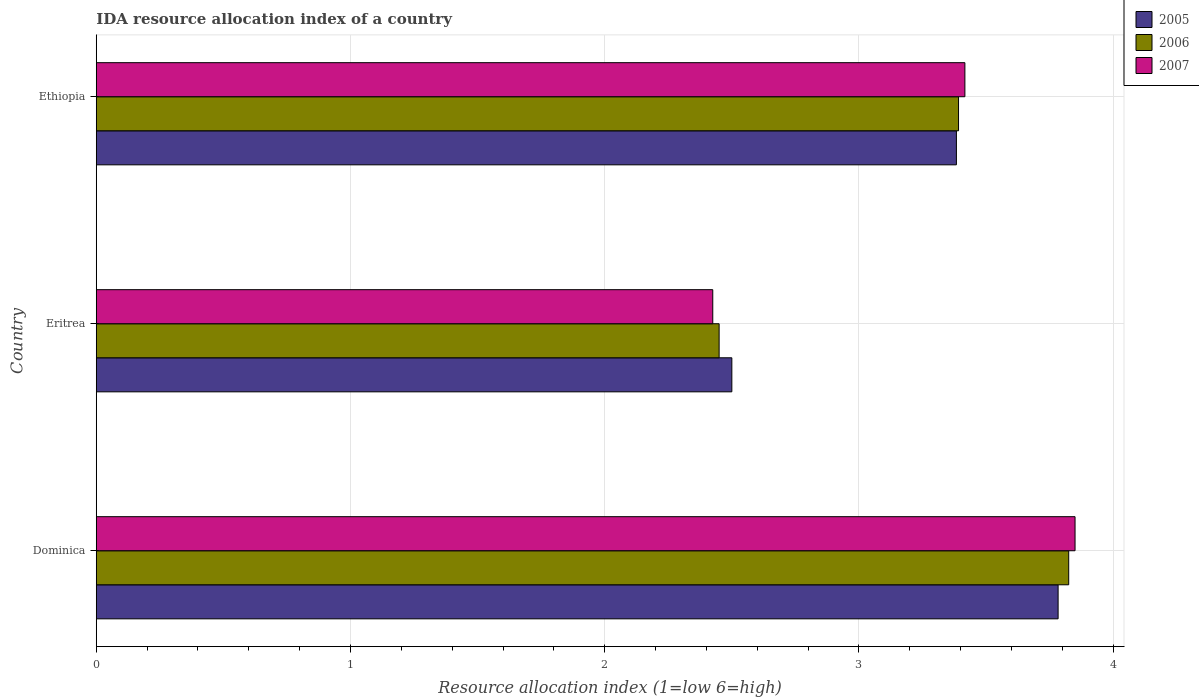Are the number of bars per tick equal to the number of legend labels?
Give a very brief answer. Yes. Are the number of bars on each tick of the Y-axis equal?
Offer a very short reply. Yes. How many bars are there on the 1st tick from the top?
Offer a terse response. 3. What is the label of the 3rd group of bars from the top?
Provide a succinct answer. Dominica. In how many cases, is the number of bars for a given country not equal to the number of legend labels?
Provide a short and direct response. 0. What is the IDA resource allocation index in 2006 in Eritrea?
Ensure brevity in your answer.  2.45. Across all countries, what is the maximum IDA resource allocation index in 2006?
Provide a succinct answer. 3.83. Across all countries, what is the minimum IDA resource allocation index in 2005?
Your answer should be compact. 2.5. In which country was the IDA resource allocation index in 2005 maximum?
Ensure brevity in your answer.  Dominica. In which country was the IDA resource allocation index in 2006 minimum?
Your answer should be very brief. Eritrea. What is the total IDA resource allocation index in 2006 in the graph?
Provide a succinct answer. 9.67. What is the difference between the IDA resource allocation index in 2005 in Dominica and that in Eritrea?
Give a very brief answer. 1.28. What is the difference between the IDA resource allocation index in 2005 in Dominica and the IDA resource allocation index in 2007 in Ethiopia?
Provide a succinct answer. 0.37. What is the average IDA resource allocation index in 2006 per country?
Make the answer very short. 3.22. What is the difference between the IDA resource allocation index in 2005 and IDA resource allocation index in 2007 in Dominica?
Offer a terse response. -0.07. What is the ratio of the IDA resource allocation index in 2007 in Dominica to that in Eritrea?
Your answer should be very brief. 1.59. Is the IDA resource allocation index in 2006 in Dominica less than that in Ethiopia?
Provide a short and direct response. No. What is the difference between the highest and the second highest IDA resource allocation index in 2006?
Offer a terse response. 0.43. What is the difference between the highest and the lowest IDA resource allocation index in 2006?
Provide a short and direct response. 1.38. Is it the case that in every country, the sum of the IDA resource allocation index in 2006 and IDA resource allocation index in 2005 is greater than the IDA resource allocation index in 2007?
Provide a succinct answer. Yes. How many bars are there?
Give a very brief answer. 9. What is the difference between two consecutive major ticks on the X-axis?
Your answer should be very brief. 1. Does the graph contain any zero values?
Provide a succinct answer. No. Does the graph contain grids?
Offer a terse response. Yes. How many legend labels are there?
Your answer should be very brief. 3. What is the title of the graph?
Offer a very short reply. IDA resource allocation index of a country. What is the label or title of the X-axis?
Your answer should be very brief. Resource allocation index (1=low 6=high). What is the label or title of the Y-axis?
Give a very brief answer. Country. What is the Resource allocation index (1=low 6=high) of 2005 in Dominica?
Ensure brevity in your answer.  3.78. What is the Resource allocation index (1=low 6=high) in 2006 in Dominica?
Offer a terse response. 3.83. What is the Resource allocation index (1=low 6=high) of 2007 in Dominica?
Make the answer very short. 3.85. What is the Resource allocation index (1=low 6=high) of 2006 in Eritrea?
Provide a succinct answer. 2.45. What is the Resource allocation index (1=low 6=high) in 2007 in Eritrea?
Your answer should be very brief. 2.42. What is the Resource allocation index (1=low 6=high) in 2005 in Ethiopia?
Offer a terse response. 3.38. What is the Resource allocation index (1=low 6=high) in 2006 in Ethiopia?
Offer a very short reply. 3.39. What is the Resource allocation index (1=low 6=high) of 2007 in Ethiopia?
Keep it short and to the point. 3.42. Across all countries, what is the maximum Resource allocation index (1=low 6=high) in 2005?
Your response must be concise. 3.78. Across all countries, what is the maximum Resource allocation index (1=low 6=high) in 2006?
Make the answer very short. 3.83. Across all countries, what is the maximum Resource allocation index (1=low 6=high) in 2007?
Provide a succinct answer. 3.85. Across all countries, what is the minimum Resource allocation index (1=low 6=high) in 2006?
Provide a succinct answer. 2.45. Across all countries, what is the minimum Resource allocation index (1=low 6=high) of 2007?
Ensure brevity in your answer.  2.42. What is the total Resource allocation index (1=low 6=high) in 2005 in the graph?
Your response must be concise. 9.67. What is the total Resource allocation index (1=low 6=high) in 2006 in the graph?
Your answer should be compact. 9.67. What is the total Resource allocation index (1=low 6=high) of 2007 in the graph?
Offer a very short reply. 9.69. What is the difference between the Resource allocation index (1=low 6=high) of 2005 in Dominica and that in Eritrea?
Provide a short and direct response. 1.28. What is the difference between the Resource allocation index (1=low 6=high) in 2006 in Dominica and that in Eritrea?
Keep it short and to the point. 1.38. What is the difference between the Resource allocation index (1=low 6=high) in 2007 in Dominica and that in Eritrea?
Your answer should be very brief. 1.43. What is the difference between the Resource allocation index (1=low 6=high) in 2006 in Dominica and that in Ethiopia?
Provide a succinct answer. 0.43. What is the difference between the Resource allocation index (1=low 6=high) in 2007 in Dominica and that in Ethiopia?
Your answer should be compact. 0.43. What is the difference between the Resource allocation index (1=low 6=high) of 2005 in Eritrea and that in Ethiopia?
Your answer should be compact. -0.88. What is the difference between the Resource allocation index (1=low 6=high) of 2006 in Eritrea and that in Ethiopia?
Your response must be concise. -0.94. What is the difference between the Resource allocation index (1=low 6=high) in 2007 in Eritrea and that in Ethiopia?
Ensure brevity in your answer.  -0.99. What is the difference between the Resource allocation index (1=low 6=high) of 2005 in Dominica and the Resource allocation index (1=low 6=high) of 2006 in Eritrea?
Make the answer very short. 1.33. What is the difference between the Resource allocation index (1=low 6=high) in 2005 in Dominica and the Resource allocation index (1=low 6=high) in 2007 in Eritrea?
Offer a terse response. 1.36. What is the difference between the Resource allocation index (1=low 6=high) of 2005 in Dominica and the Resource allocation index (1=low 6=high) of 2006 in Ethiopia?
Your answer should be compact. 0.39. What is the difference between the Resource allocation index (1=low 6=high) of 2005 in Dominica and the Resource allocation index (1=low 6=high) of 2007 in Ethiopia?
Provide a succinct answer. 0.37. What is the difference between the Resource allocation index (1=low 6=high) in 2006 in Dominica and the Resource allocation index (1=low 6=high) in 2007 in Ethiopia?
Your answer should be compact. 0.41. What is the difference between the Resource allocation index (1=low 6=high) of 2005 in Eritrea and the Resource allocation index (1=low 6=high) of 2006 in Ethiopia?
Offer a terse response. -0.89. What is the difference between the Resource allocation index (1=low 6=high) in 2005 in Eritrea and the Resource allocation index (1=low 6=high) in 2007 in Ethiopia?
Your answer should be very brief. -0.92. What is the difference between the Resource allocation index (1=low 6=high) in 2006 in Eritrea and the Resource allocation index (1=low 6=high) in 2007 in Ethiopia?
Your answer should be compact. -0.97. What is the average Resource allocation index (1=low 6=high) of 2005 per country?
Make the answer very short. 3.22. What is the average Resource allocation index (1=low 6=high) in 2006 per country?
Your answer should be compact. 3.22. What is the average Resource allocation index (1=low 6=high) of 2007 per country?
Make the answer very short. 3.23. What is the difference between the Resource allocation index (1=low 6=high) in 2005 and Resource allocation index (1=low 6=high) in 2006 in Dominica?
Keep it short and to the point. -0.04. What is the difference between the Resource allocation index (1=low 6=high) of 2005 and Resource allocation index (1=low 6=high) of 2007 in Dominica?
Offer a terse response. -0.07. What is the difference between the Resource allocation index (1=low 6=high) of 2006 and Resource allocation index (1=low 6=high) of 2007 in Dominica?
Your response must be concise. -0.03. What is the difference between the Resource allocation index (1=low 6=high) of 2005 and Resource allocation index (1=low 6=high) of 2007 in Eritrea?
Offer a very short reply. 0.07. What is the difference between the Resource allocation index (1=low 6=high) in 2006 and Resource allocation index (1=low 6=high) in 2007 in Eritrea?
Your response must be concise. 0.03. What is the difference between the Resource allocation index (1=low 6=high) in 2005 and Resource allocation index (1=low 6=high) in 2006 in Ethiopia?
Offer a terse response. -0.01. What is the difference between the Resource allocation index (1=low 6=high) in 2005 and Resource allocation index (1=low 6=high) in 2007 in Ethiopia?
Provide a short and direct response. -0.03. What is the difference between the Resource allocation index (1=low 6=high) of 2006 and Resource allocation index (1=low 6=high) of 2007 in Ethiopia?
Provide a succinct answer. -0.03. What is the ratio of the Resource allocation index (1=low 6=high) in 2005 in Dominica to that in Eritrea?
Make the answer very short. 1.51. What is the ratio of the Resource allocation index (1=low 6=high) of 2006 in Dominica to that in Eritrea?
Provide a short and direct response. 1.56. What is the ratio of the Resource allocation index (1=low 6=high) of 2007 in Dominica to that in Eritrea?
Offer a very short reply. 1.59. What is the ratio of the Resource allocation index (1=low 6=high) in 2005 in Dominica to that in Ethiopia?
Your answer should be compact. 1.12. What is the ratio of the Resource allocation index (1=low 6=high) in 2006 in Dominica to that in Ethiopia?
Give a very brief answer. 1.13. What is the ratio of the Resource allocation index (1=low 6=high) in 2007 in Dominica to that in Ethiopia?
Provide a succinct answer. 1.13. What is the ratio of the Resource allocation index (1=low 6=high) of 2005 in Eritrea to that in Ethiopia?
Offer a very short reply. 0.74. What is the ratio of the Resource allocation index (1=low 6=high) of 2006 in Eritrea to that in Ethiopia?
Ensure brevity in your answer.  0.72. What is the ratio of the Resource allocation index (1=low 6=high) of 2007 in Eritrea to that in Ethiopia?
Provide a succinct answer. 0.71. What is the difference between the highest and the second highest Resource allocation index (1=low 6=high) of 2006?
Provide a short and direct response. 0.43. What is the difference between the highest and the second highest Resource allocation index (1=low 6=high) of 2007?
Keep it short and to the point. 0.43. What is the difference between the highest and the lowest Resource allocation index (1=low 6=high) of 2005?
Offer a terse response. 1.28. What is the difference between the highest and the lowest Resource allocation index (1=low 6=high) in 2006?
Keep it short and to the point. 1.38. What is the difference between the highest and the lowest Resource allocation index (1=low 6=high) of 2007?
Ensure brevity in your answer.  1.43. 